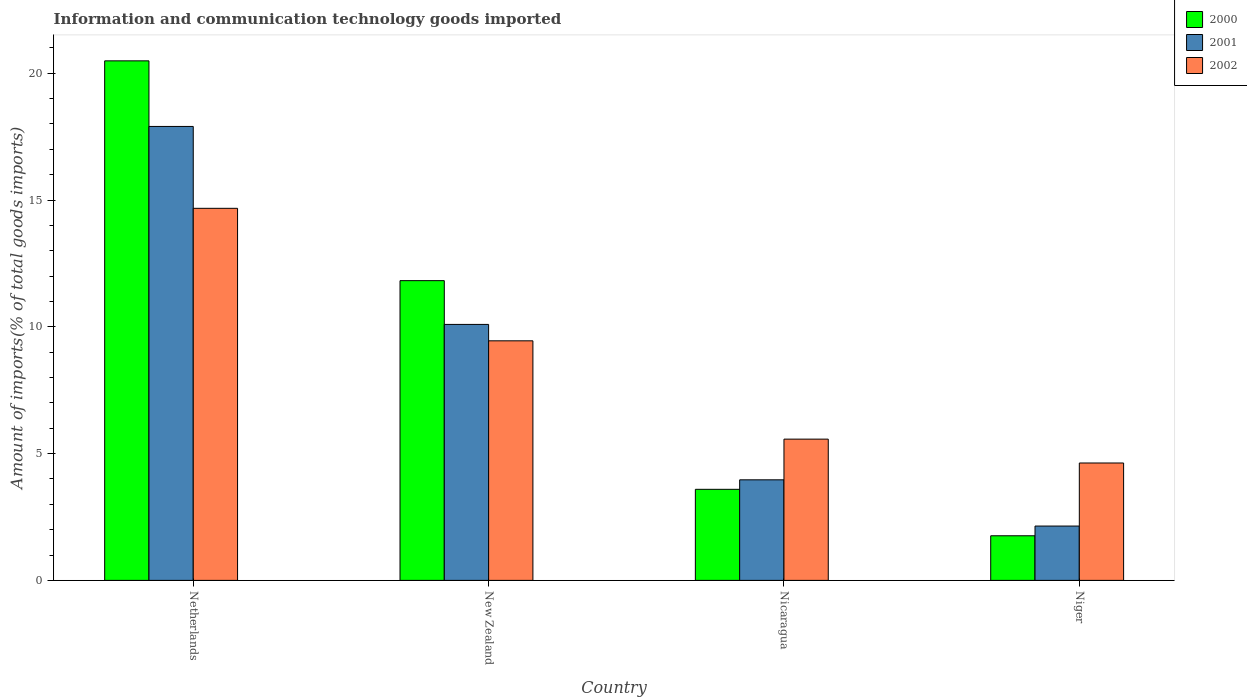How many different coloured bars are there?
Provide a succinct answer. 3. Are the number of bars per tick equal to the number of legend labels?
Give a very brief answer. Yes. How many bars are there on the 4th tick from the left?
Offer a very short reply. 3. How many bars are there on the 4th tick from the right?
Your answer should be compact. 3. What is the label of the 1st group of bars from the left?
Keep it short and to the point. Netherlands. In how many cases, is the number of bars for a given country not equal to the number of legend labels?
Your answer should be compact. 0. What is the amount of goods imported in 2002 in New Zealand?
Make the answer very short. 9.45. Across all countries, what is the maximum amount of goods imported in 2001?
Provide a succinct answer. 17.9. Across all countries, what is the minimum amount of goods imported in 2002?
Your answer should be very brief. 4.63. In which country was the amount of goods imported in 2001 minimum?
Ensure brevity in your answer.  Niger. What is the total amount of goods imported in 2000 in the graph?
Keep it short and to the point. 37.66. What is the difference between the amount of goods imported in 2002 in New Zealand and that in Nicaragua?
Your answer should be compact. 3.88. What is the difference between the amount of goods imported in 2002 in Nicaragua and the amount of goods imported in 2001 in New Zealand?
Make the answer very short. -4.52. What is the average amount of goods imported in 2001 per country?
Ensure brevity in your answer.  8.53. What is the difference between the amount of goods imported of/in 2002 and amount of goods imported of/in 2001 in New Zealand?
Your response must be concise. -0.65. In how many countries, is the amount of goods imported in 2001 greater than 10 %?
Make the answer very short. 2. What is the ratio of the amount of goods imported in 2001 in New Zealand to that in Nicaragua?
Your answer should be compact. 2.55. Is the difference between the amount of goods imported in 2002 in New Zealand and Nicaragua greater than the difference between the amount of goods imported in 2001 in New Zealand and Nicaragua?
Ensure brevity in your answer.  No. What is the difference between the highest and the second highest amount of goods imported in 2001?
Your response must be concise. 7.81. What is the difference between the highest and the lowest amount of goods imported in 2000?
Your answer should be compact. 18.73. In how many countries, is the amount of goods imported in 2001 greater than the average amount of goods imported in 2001 taken over all countries?
Keep it short and to the point. 2. Is the sum of the amount of goods imported in 2002 in Netherlands and Niger greater than the maximum amount of goods imported in 2001 across all countries?
Provide a succinct answer. Yes. What does the 1st bar from the left in Netherlands represents?
Ensure brevity in your answer.  2000. What does the 3rd bar from the right in Netherlands represents?
Make the answer very short. 2000. Are all the bars in the graph horizontal?
Your response must be concise. No. How many countries are there in the graph?
Provide a succinct answer. 4. How many legend labels are there?
Offer a very short reply. 3. What is the title of the graph?
Give a very brief answer. Information and communication technology goods imported. Does "2011" appear as one of the legend labels in the graph?
Your answer should be very brief. No. What is the label or title of the Y-axis?
Your response must be concise. Amount of imports(% of total goods imports). What is the Amount of imports(% of total goods imports) of 2000 in Netherlands?
Your response must be concise. 20.49. What is the Amount of imports(% of total goods imports) of 2001 in Netherlands?
Offer a very short reply. 17.9. What is the Amount of imports(% of total goods imports) of 2002 in Netherlands?
Your response must be concise. 14.67. What is the Amount of imports(% of total goods imports) of 2000 in New Zealand?
Provide a succinct answer. 11.82. What is the Amount of imports(% of total goods imports) of 2001 in New Zealand?
Make the answer very short. 10.1. What is the Amount of imports(% of total goods imports) in 2002 in New Zealand?
Your answer should be very brief. 9.45. What is the Amount of imports(% of total goods imports) in 2000 in Nicaragua?
Offer a very short reply. 3.59. What is the Amount of imports(% of total goods imports) of 2001 in Nicaragua?
Provide a short and direct response. 3.97. What is the Amount of imports(% of total goods imports) of 2002 in Nicaragua?
Provide a short and direct response. 5.57. What is the Amount of imports(% of total goods imports) in 2000 in Niger?
Offer a terse response. 1.76. What is the Amount of imports(% of total goods imports) in 2001 in Niger?
Your answer should be compact. 2.14. What is the Amount of imports(% of total goods imports) in 2002 in Niger?
Your answer should be very brief. 4.63. Across all countries, what is the maximum Amount of imports(% of total goods imports) of 2000?
Your response must be concise. 20.49. Across all countries, what is the maximum Amount of imports(% of total goods imports) of 2001?
Keep it short and to the point. 17.9. Across all countries, what is the maximum Amount of imports(% of total goods imports) in 2002?
Give a very brief answer. 14.67. Across all countries, what is the minimum Amount of imports(% of total goods imports) of 2000?
Offer a very short reply. 1.76. Across all countries, what is the minimum Amount of imports(% of total goods imports) in 2001?
Your answer should be very brief. 2.14. Across all countries, what is the minimum Amount of imports(% of total goods imports) in 2002?
Give a very brief answer. 4.63. What is the total Amount of imports(% of total goods imports) in 2000 in the graph?
Offer a terse response. 37.66. What is the total Amount of imports(% of total goods imports) in 2001 in the graph?
Your answer should be compact. 34.11. What is the total Amount of imports(% of total goods imports) of 2002 in the graph?
Your response must be concise. 34.32. What is the difference between the Amount of imports(% of total goods imports) of 2000 in Netherlands and that in New Zealand?
Make the answer very short. 8.67. What is the difference between the Amount of imports(% of total goods imports) of 2001 in Netherlands and that in New Zealand?
Keep it short and to the point. 7.81. What is the difference between the Amount of imports(% of total goods imports) in 2002 in Netherlands and that in New Zealand?
Offer a terse response. 5.23. What is the difference between the Amount of imports(% of total goods imports) of 2000 in Netherlands and that in Nicaragua?
Give a very brief answer. 16.9. What is the difference between the Amount of imports(% of total goods imports) in 2001 in Netherlands and that in Nicaragua?
Ensure brevity in your answer.  13.94. What is the difference between the Amount of imports(% of total goods imports) in 2002 in Netherlands and that in Nicaragua?
Offer a terse response. 9.1. What is the difference between the Amount of imports(% of total goods imports) in 2000 in Netherlands and that in Niger?
Make the answer very short. 18.73. What is the difference between the Amount of imports(% of total goods imports) in 2001 in Netherlands and that in Niger?
Your answer should be very brief. 15.76. What is the difference between the Amount of imports(% of total goods imports) of 2002 in Netherlands and that in Niger?
Give a very brief answer. 10.04. What is the difference between the Amount of imports(% of total goods imports) of 2000 in New Zealand and that in Nicaragua?
Make the answer very short. 8.23. What is the difference between the Amount of imports(% of total goods imports) in 2001 in New Zealand and that in Nicaragua?
Your answer should be compact. 6.13. What is the difference between the Amount of imports(% of total goods imports) in 2002 in New Zealand and that in Nicaragua?
Offer a very short reply. 3.88. What is the difference between the Amount of imports(% of total goods imports) of 2000 in New Zealand and that in Niger?
Offer a terse response. 10.06. What is the difference between the Amount of imports(% of total goods imports) in 2001 in New Zealand and that in Niger?
Make the answer very short. 7.95. What is the difference between the Amount of imports(% of total goods imports) in 2002 in New Zealand and that in Niger?
Provide a succinct answer. 4.82. What is the difference between the Amount of imports(% of total goods imports) of 2000 in Nicaragua and that in Niger?
Give a very brief answer. 1.83. What is the difference between the Amount of imports(% of total goods imports) of 2001 in Nicaragua and that in Niger?
Your answer should be very brief. 1.82. What is the difference between the Amount of imports(% of total goods imports) of 2002 in Nicaragua and that in Niger?
Keep it short and to the point. 0.94. What is the difference between the Amount of imports(% of total goods imports) of 2000 in Netherlands and the Amount of imports(% of total goods imports) of 2001 in New Zealand?
Provide a short and direct response. 10.39. What is the difference between the Amount of imports(% of total goods imports) in 2000 in Netherlands and the Amount of imports(% of total goods imports) in 2002 in New Zealand?
Your answer should be compact. 11.04. What is the difference between the Amount of imports(% of total goods imports) of 2001 in Netherlands and the Amount of imports(% of total goods imports) of 2002 in New Zealand?
Your answer should be very brief. 8.46. What is the difference between the Amount of imports(% of total goods imports) in 2000 in Netherlands and the Amount of imports(% of total goods imports) in 2001 in Nicaragua?
Your response must be concise. 16.52. What is the difference between the Amount of imports(% of total goods imports) in 2000 in Netherlands and the Amount of imports(% of total goods imports) in 2002 in Nicaragua?
Make the answer very short. 14.92. What is the difference between the Amount of imports(% of total goods imports) of 2001 in Netherlands and the Amount of imports(% of total goods imports) of 2002 in Nicaragua?
Your response must be concise. 12.33. What is the difference between the Amount of imports(% of total goods imports) in 2000 in Netherlands and the Amount of imports(% of total goods imports) in 2001 in Niger?
Give a very brief answer. 18.35. What is the difference between the Amount of imports(% of total goods imports) in 2000 in Netherlands and the Amount of imports(% of total goods imports) in 2002 in Niger?
Your answer should be very brief. 15.86. What is the difference between the Amount of imports(% of total goods imports) of 2001 in Netherlands and the Amount of imports(% of total goods imports) of 2002 in Niger?
Give a very brief answer. 13.27. What is the difference between the Amount of imports(% of total goods imports) of 2000 in New Zealand and the Amount of imports(% of total goods imports) of 2001 in Nicaragua?
Offer a terse response. 7.86. What is the difference between the Amount of imports(% of total goods imports) in 2000 in New Zealand and the Amount of imports(% of total goods imports) in 2002 in Nicaragua?
Offer a terse response. 6.25. What is the difference between the Amount of imports(% of total goods imports) of 2001 in New Zealand and the Amount of imports(% of total goods imports) of 2002 in Nicaragua?
Make the answer very short. 4.52. What is the difference between the Amount of imports(% of total goods imports) in 2000 in New Zealand and the Amount of imports(% of total goods imports) in 2001 in Niger?
Ensure brevity in your answer.  9.68. What is the difference between the Amount of imports(% of total goods imports) of 2000 in New Zealand and the Amount of imports(% of total goods imports) of 2002 in Niger?
Your answer should be very brief. 7.19. What is the difference between the Amount of imports(% of total goods imports) in 2001 in New Zealand and the Amount of imports(% of total goods imports) in 2002 in Niger?
Provide a short and direct response. 5.47. What is the difference between the Amount of imports(% of total goods imports) in 2000 in Nicaragua and the Amount of imports(% of total goods imports) in 2001 in Niger?
Keep it short and to the point. 1.45. What is the difference between the Amount of imports(% of total goods imports) of 2000 in Nicaragua and the Amount of imports(% of total goods imports) of 2002 in Niger?
Provide a short and direct response. -1.04. What is the difference between the Amount of imports(% of total goods imports) in 2001 in Nicaragua and the Amount of imports(% of total goods imports) in 2002 in Niger?
Ensure brevity in your answer.  -0.66. What is the average Amount of imports(% of total goods imports) of 2000 per country?
Offer a very short reply. 9.42. What is the average Amount of imports(% of total goods imports) of 2001 per country?
Your response must be concise. 8.53. What is the average Amount of imports(% of total goods imports) in 2002 per country?
Your response must be concise. 8.58. What is the difference between the Amount of imports(% of total goods imports) in 2000 and Amount of imports(% of total goods imports) in 2001 in Netherlands?
Provide a succinct answer. 2.59. What is the difference between the Amount of imports(% of total goods imports) in 2000 and Amount of imports(% of total goods imports) in 2002 in Netherlands?
Offer a very short reply. 5.82. What is the difference between the Amount of imports(% of total goods imports) of 2001 and Amount of imports(% of total goods imports) of 2002 in Netherlands?
Provide a short and direct response. 3.23. What is the difference between the Amount of imports(% of total goods imports) in 2000 and Amount of imports(% of total goods imports) in 2001 in New Zealand?
Provide a succinct answer. 1.73. What is the difference between the Amount of imports(% of total goods imports) of 2000 and Amount of imports(% of total goods imports) of 2002 in New Zealand?
Provide a succinct answer. 2.37. What is the difference between the Amount of imports(% of total goods imports) in 2001 and Amount of imports(% of total goods imports) in 2002 in New Zealand?
Ensure brevity in your answer.  0.65. What is the difference between the Amount of imports(% of total goods imports) of 2000 and Amount of imports(% of total goods imports) of 2001 in Nicaragua?
Provide a short and direct response. -0.37. What is the difference between the Amount of imports(% of total goods imports) in 2000 and Amount of imports(% of total goods imports) in 2002 in Nicaragua?
Ensure brevity in your answer.  -1.98. What is the difference between the Amount of imports(% of total goods imports) in 2001 and Amount of imports(% of total goods imports) in 2002 in Nicaragua?
Give a very brief answer. -1.6. What is the difference between the Amount of imports(% of total goods imports) of 2000 and Amount of imports(% of total goods imports) of 2001 in Niger?
Make the answer very short. -0.38. What is the difference between the Amount of imports(% of total goods imports) of 2000 and Amount of imports(% of total goods imports) of 2002 in Niger?
Your answer should be very brief. -2.87. What is the difference between the Amount of imports(% of total goods imports) in 2001 and Amount of imports(% of total goods imports) in 2002 in Niger?
Ensure brevity in your answer.  -2.49. What is the ratio of the Amount of imports(% of total goods imports) of 2000 in Netherlands to that in New Zealand?
Provide a short and direct response. 1.73. What is the ratio of the Amount of imports(% of total goods imports) in 2001 in Netherlands to that in New Zealand?
Ensure brevity in your answer.  1.77. What is the ratio of the Amount of imports(% of total goods imports) of 2002 in Netherlands to that in New Zealand?
Ensure brevity in your answer.  1.55. What is the ratio of the Amount of imports(% of total goods imports) of 2000 in Netherlands to that in Nicaragua?
Offer a terse response. 5.7. What is the ratio of the Amount of imports(% of total goods imports) in 2001 in Netherlands to that in Nicaragua?
Your answer should be compact. 4.51. What is the ratio of the Amount of imports(% of total goods imports) of 2002 in Netherlands to that in Nicaragua?
Your answer should be very brief. 2.63. What is the ratio of the Amount of imports(% of total goods imports) in 2000 in Netherlands to that in Niger?
Your response must be concise. 11.64. What is the ratio of the Amount of imports(% of total goods imports) of 2001 in Netherlands to that in Niger?
Give a very brief answer. 8.35. What is the ratio of the Amount of imports(% of total goods imports) of 2002 in Netherlands to that in Niger?
Offer a very short reply. 3.17. What is the ratio of the Amount of imports(% of total goods imports) of 2000 in New Zealand to that in Nicaragua?
Give a very brief answer. 3.29. What is the ratio of the Amount of imports(% of total goods imports) of 2001 in New Zealand to that in Nicaragua?
Your answer should be compact. 2.55. What is the ratio of the Amount of imports(% of total goods imports) of 2002 in New Zealand to that in Nicaragua?
Keep it short and to the point. 1.7. What is the ratio of the Amount of imports(% of total goods imports) in 2000 in New Zealand to that in Niger?
Your response must be concise. 6.72. What is the ratio of the Amount of imports(% of total goods imports) of 2001 in New Zealand to that in Niger?
Make the answer very short. 4.71. What is the ratio of the Amount of imports(% of total goods imports) of 2002 in New Zealand to that in Niger?
Offer a terse response. 2.04. What is the ratio of the Amount of imports(% of total goods imports) of 2000 in Nicaragua to that in Niger?
Your response must be concise. 2.04. What is the ratio of the Amount of imports(% of total goods imports) in 2001 in Nicaragua to that in Niger?
Your answer should be compact. 1.85. What is the ratio of the Amount of imports(% of total goods imports) in 2002 in Nicaragua to that in Niger?
Offer a very short reply. 1.2. What is the difference between the highest and the second highest Amount of imports(% of total goods imports) in 2000?
Provide a short and direct response. 8.67. What is the difference between the highest and the second highest Amount of imports(% of total goods imports) in 2001?
Provide a short and direct response. 7.81. What is the difference between the highest and the second highest Amount of imports(% of total goods imports) of 2002?
Your answer should be compact. 5.23. What is the difference between the highest and the lowest Amount of imports(% of total goods imports) in 2000?
Your answer should be compact. 18.73. What is the difference between the highest and the lowest Amount of imports(% of total goods imports) of 2001?
Keep it short and to the point. 15.76. What is the difference between the highest and the lowest Amount of imports(% of total goods imports) of 2002?
Make the answer very short. 10.04. 